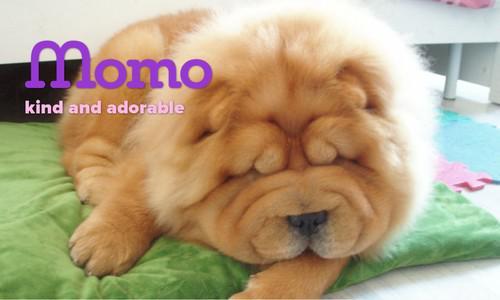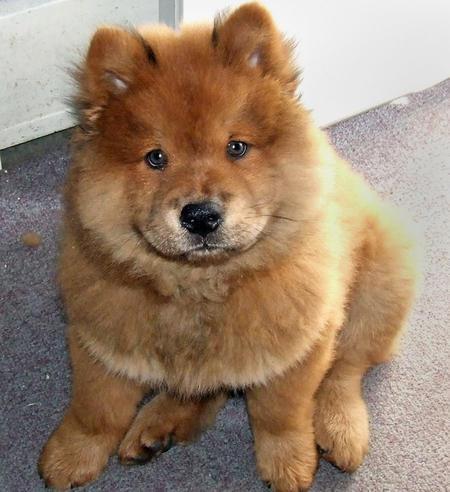The first image is the image on the left, the second image is the image on the right. Given the left and right images, does the statement "Exactly two dogs can be seen to be standing, and have their white tails curled up and laying on their backs" hold true? Answer yes or no. No. The first image is the image on the left, the second image is the image on the right. Evaluate the accuracy of this statement regarding the images: "The dog in the right image is looking towards the right.". Is it true? Answer yes or no. No. 